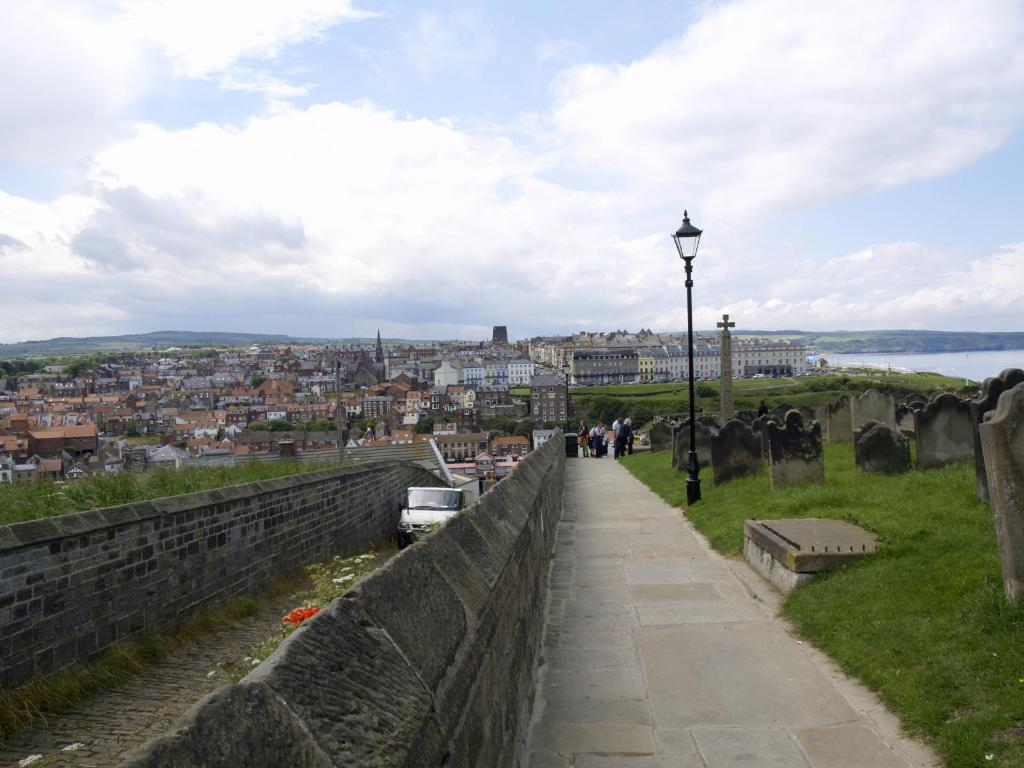What type of landscape is depicted in the image? There is grassland in the image. What object can be seen on the right side of the image? There is a pole on the right side of the image. What structures are located in the center of the image? There are buildings in the center of the image. What is visible at the top of the image? The sky is visible at the top of the image. What color is the sock hanging on the pole in the image? There is no sock present in the image; it only features a pole and other elements mentioned in the facts. 